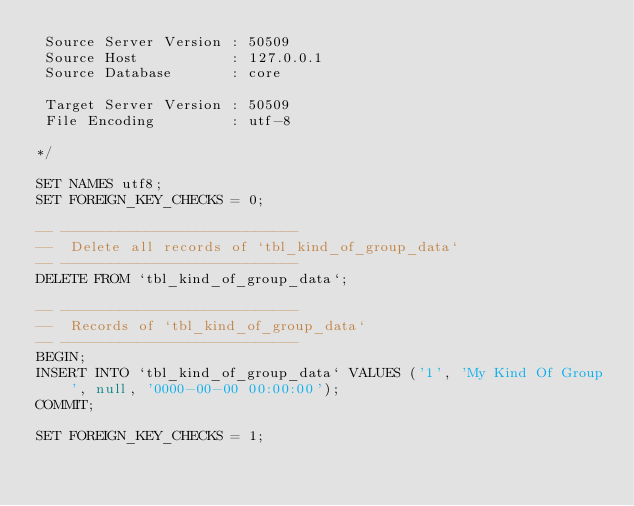<code> <loc_0><loc_0><loc_500><loc_500><_SQL_> Source Server Version : 50509
 Source Host           : 127.0.0.1
 Source Database       : core

 Target Server Version : 50509
 File Encoding         : utf-8

*/

SET NAMES utf8;
SET FOREIGN_KEY_CHECKS = 0;

-- ----------------------------
--  Delete all records of `tbl_kind_of_group_data`
-- ----------------------------
DELETE FROM `tbl_kind_of_group_data`;

-- ----------------------------
--  Records of `tbl_kind_of_group_data`
-- ----------------------------
BEGIN;
INSERT INTO `tbl_kind_of_group_data` VALUES ('1', 'My Kind Of Group', null, '0000-00-00 00:00:00');
COMMIT;

SET FOREIGN_KEY_CHECKS = 1;
</code> 